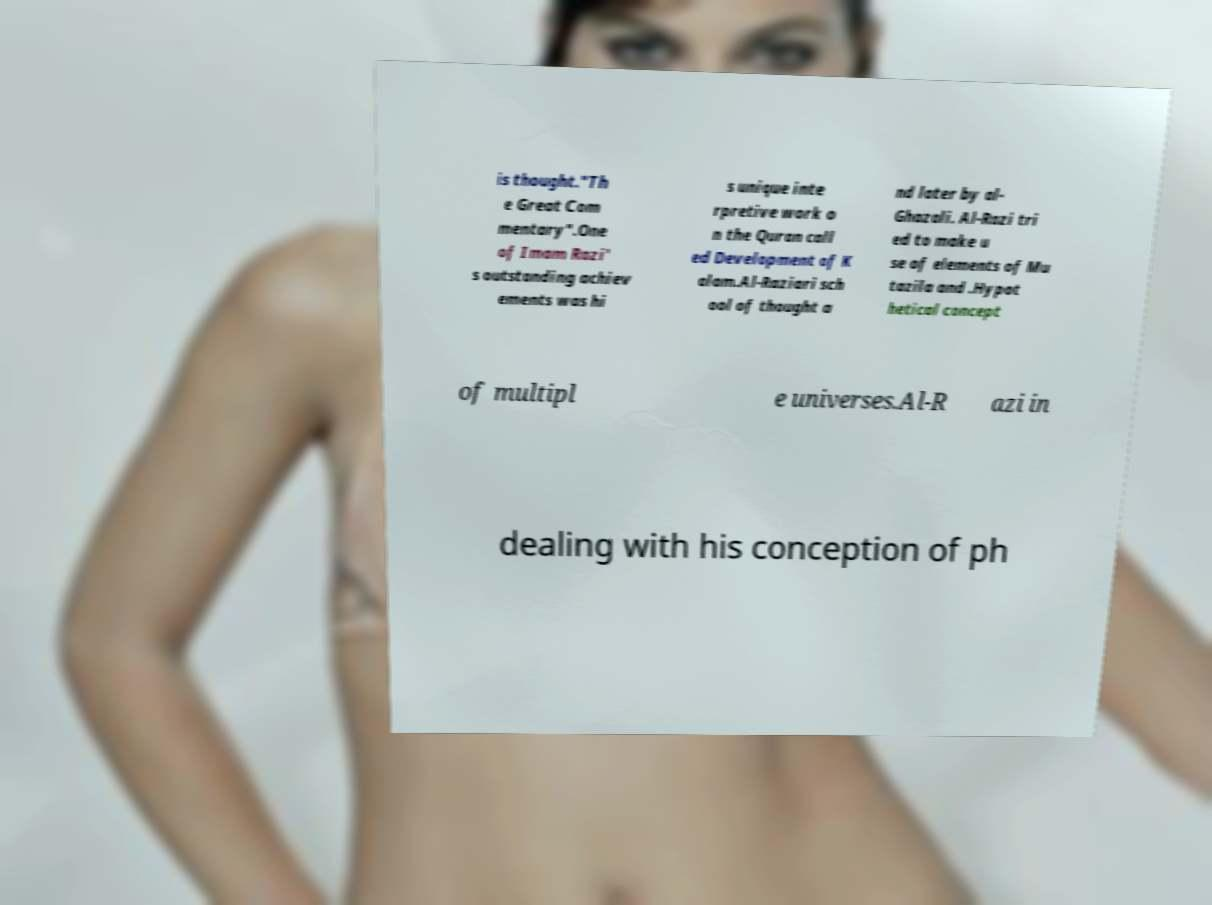Could you extract and type out the text from this image? is thought."Th e Great Com mentary".One of Imam Razi' s outstanding achiev ements was hi s unique inte rpretive work o n the Quran call ed Development of K alam.Al-Raziari sch ool of thought a nd later by al- Ghazali. Al-Razi tri ed to make u se of elements of Mu tazila and .Hypot hetical concept of multipl e universes.Al-R azi in dealing with his conception of ph 